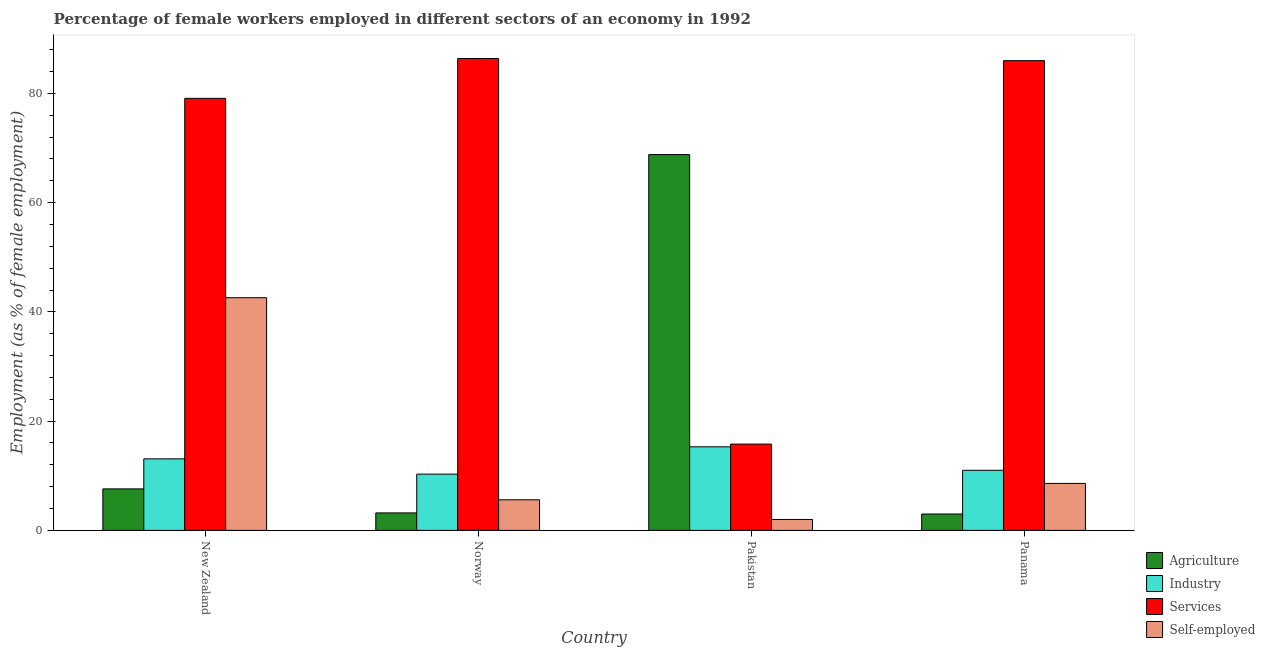How many groups of bars are there?
Offer a terse response. 4. Are the number of bars per tick equal to the number of legend labels?
Offer a very short reply. Yes. Are the number of bars on each tick of the X-axis equal?
Your answer should be very brief. Yes. How many bars are there on the 4th tick from the left?
Your response must be concise. 4. How many bars are there on the 3rd tick from the right?
Offer a terse response. 4. What is the label of the 4th group of bars from the left?
Make the answer very short. Panama. What is the percentage of female workers in services in Pakistan?
Make the answer very short. 15.8. Across all countries, what is the maximum percentage of female workers in services?
Offer a terse response. 86.4. Across all countries, what is the minimum percentage of self employed female workers?
Provide a succinct answer. 2. In which country was the percentage of female workers in industry minimum?
Offer a terse response. Norway. What is the total percentage of female workers in services in the graph?
Offer a terse response. 267.3. What is the difference between the percentage of female workers in industry in Norway and that in Pakistan?
Keep it short and to the point. -5. What is the difference between the percentage of female workers in agriculture in New Zealand and the percentage of self employed female workers in Pakistan?
Make the answer very short. 5.6. What is the average percentage of female workers in agriculture per country?
Give a very brief answer. 20.65. What is the difference between the percentage of female workers in services and percentage of female workers in industry in New Zealand?
Offer a terse response. 66. In how many countries, is the percentage of self employed female workers greater than 8 %?
Your answer should be very brief. 2. What is the ratio of the percentage of female workers in agriculture in Norway to that in Panama?
Give a very brief answer. 1.07. Is the percentage of female workers in industry in Norway less than that in Pakistan?
Provide a short and direct response. Yes. Is the difference between the percentage of female workers in industry in New Zealand and Norway greater than the difference between the percentage of self employed female workers in New Zealand and Norway?
Ensure brevity in your answer.  No. What is the difference between the highest and the second highest percentage of self employed female workers?
Ensure brevity in your answer.  34. Is it the case that in every country, the sum of the percentage of self employed female workers and percentage of female workers in services is greater than the sum of percentage of female workers in agriculture and percentage of female workers in industry?
Keep it short and to the point. No. What does the 3rd bar from the left in Pakistan represents?
Offer a very short reply. Services. What does the 1st bar from the right in Norway represents?
Your response must be concise. Self-employed. Is it the case that in every country, the sum of the percentage of female workers in agriculture and percentage of female workers in industry is greater than the percentage of female workers in services?
Give a very brief answer. No. What is the difference between two consecutive major ticks on the Y-axis?
Provide a short and direct response. 20. Are the values on the major ticks of Y-axis written in scientific E-notation?
Your answer should be very brief. No. Where does the legend appear in the graph?
Give a very brief answer. Bottom right. How are the legend labels stacked?
Offer a terse response. Vertical. What is the title of the graph?
Your answer should be compact. Percentage of female workers employed in different sectors of an economy in 1992. Does "First 20% of population" appear as one of the legend labels in the graph?
Provide a short and direct response. No. What is the label or title of the X-axis?
Your response must be concise. Country. What is the label or title of the Y-axis?
Offer a very short reply. Employment (as % of female employment). What is the Employment (as % of female employment) in Agriculture in New Zealand?
Your answer should be very brief. 7.6. What is the Employment (as % of female employment) in Industry in New Zealand?
Offer a terse response. 13.1. What is the Employment (as % of female employment) in Services in New Zealand?
Your answer should be compact. 79.1. What is the Employment (as % of female employment) of Self-employed in New Zealand?
Your response must be concise. 42.6. What is the Employment (as % of female employment) in Agriculture in Norway?
Provide a succinct answer. 3.2. What is the Employment (as % of female employment) in Industry in Norway?
Your answer should be very brief. 10.3. What is the Employment (as % of female employment) in Services in Norway?
Give a very brief answer. 86.4. What is the Employment (as % of female employment) in Self-employed in Norway?
Make the answer very short. 5.6. What is the Employment (as % of female employment) of Agriculture in Pakistan?
Your answer should be compact. 68.8. What is the Employment (as % of female employment) in Industry in Pakistan?
Your answer should be compact. 15.3. What is the Employment (as % of female employment) of Services in Pakistan?
Give a very brief answer. 15.8. What is the Employment (as % of female employment) of Industry in Panama?
Make the answer very short. 11. What is the Employment (as % of female employment) in Services in Panama?
Your answer should be compact. 86. What is the Employment (as % of female employment) of Self-employed in Panama?
Ensure brevity in your answer.  8.6. Across all countries, what is the maximum Employment (as % of female employment) of Agriculture?
Your response must be concise. 68.8. Across all countries, what is the maximum Employment (as % of female employment) of Industry?
Provide a short and direct response. 15.3. Across all countries, what is the maximum Employment (as % of female employment) in Services?
Give a very brief answer. 86.4. Across all countries, what is the maximum Employment (as % of female employment) of Self-employed?
Make the answer very short. 42.6. Across all countries, what is the minimum Employment (as % of female employment) in Agriculture?
Your response must be concise. 3. Across all countries, what is the minimum Employment (as % of female employment) of Industry?
Give a very brief answer. 10.3. Across all countries, what is the minimum Employment (as % of female employment) of Services?
Your response must be concise. 15.8. Across all countries, what is the minimum Employment (as % of female employment) in Self-employed?
Keep it short and to the point. 2. What is the total Employment (as % of female employment) of Agriculture in the graph?
Your answer should be very brief. 82.6. What is the total Employment (as % of female employment) of Industry in the graph?
Ensure brevity in your answer.  49.7. What is the total Employment (as % of female employment) in Services in the graph?
Provide a succinct answer. 267.3. What is the total Employment (as % of female employment) of Self-employed in the graph?
Give a very brief answer. 58.8. What is the difference between the Employment (as % of female employment) of Industry in New Zealand and that in Norway?
Offer a very short reply. 2.8. What is the difference between the Employment (as % of female employment) of Self-employed in New Zealand and that in Norway?
Your response must be concise. 37. What is the difference between the Employment (as % of female employment) in Agriculture in New Zealand and that in Pakistan?
Keep it short and to the point. -61.2. What is the difference between the Employment (as % of female employment) in Services in New Zealand and that in Pakistan?
Give a very brief answer. 63.3. What is the difference between the Employment (as % of female employment) of Self-employed in New Zealand and that in Pakistan?
Provide a short and direct response. 40.6. What is the difference between the Employment (as % of female employment) in Agriculture in Norway and that in Pakistan?
Offer a very short reply. -65.6. What is the difference between the Employment (as % of female employment) of Services in Norway and that in Pakistan?
Offer a very short reply. 70.6. What is the difference between the Employment (as % of female employment) of Self-employed in Norway and that in Pakistan?
Provide a short and direct response. 3.6. What is the difference between the Employment (as % of female employment) of Agriculture in Norway and that in Panama?
Your answer should be very brief. 0.2. What is the difference between the Employment (as % of female employment) of Agriculture in Pakistan and that in Panama?
Offer a very short reply. 65.8. What is the difference between the Employment (as % of female employment) in Industry in Pakistan and that in Panama?
Your response must be concise. 4.3. What is the difference between the Employment (as % of female employment) in Services in Pakistan and that in Panama?
Your response must be concise. -70.2. What is the difference between the Employment (as % of female employment) in Self-employed in Pakistan and that in Panama?
Offer a very short reply. -6.6. What is the difference between the Employment (as % of female employment) of Agriculture in New Zealand and the Employment (as % of female employment) of Industry in Norway?
Your response must be concise. -2.7. What is the difference between the Employment (as % of female employment) in Agriculture in New Zealand and the Employment (as % of female employment) in Services in Norway?
Keep it short and to the point. -78.8. What is the difference between the Employment (as % of female employment) of Industry in New Zealand and the Employment (as % of female employment) of Services in Norway?
Provide a short and direct response. -73.3. What is the difference between the Employment (as % of female employment) in Services in New Zealand and the Employment (as % of female employment) in Self-employed in Norway?
Keep it short and to the point. 73.5. What is the difference between the Employment (as % of female employment) of Agriculture in New Zealand and the Employment (as % of female employment) of Industry in Pakistan?
Your answer should be compact. -7.7. What is the difference between the Employment (as % of female employment) of Agriculture in New Zealand and the Employment (as % of female employment) of Services in Pakistan?
Your answer should be very brief. -8.2. What is the difference between the Employment (as % of female employment) of Industry in New Zealand and the Employment (as % of female employment) of Services in Pakistan?
Keep it short and to the point. -2.7. What is the difference between the Employment (as % of female employment) in Services in New Zealand and the Employment (as % of female employment) in Self-employed in Pakistan?
Make the answer very short. 77.1. What is the difference between the Employment (as % of female employment) of Agriculture in New Zealand and the Employment (as % of female employment) of Services in Panama?
Your answer should be very brief. -78.4. What is the difference between the Employment (as % of female employment) in Agriculture in New Zealand and the Employment (as % of female employment) in Self-employed in Panama?
Your answer should be very brief. -1. What is the difference between the Employment (as % of female employment) of Industry in New Zealand and the Employment (as % of female employment) of Services in Panama?
Give a very brief answer. -72.9. What is the difference between the Employment (as % of female employment) in Industry in New Zealand and the Employment (as % of female employment) in Self-employed in Panama?
Provide a succinct answer. 4.5. What is the difference between the Employment (as % of female employment) of Services in New Zealand and the Employment (as % of female employment) of Self-employed in Panama?
Make the answer very short. 70.5. What is the difference between the Employment (as % of female employment) of Agriculture in Norway and the Employment (as % of female employment) of Industry in Pakistan?
Keep it short and to the point. -12.1. What is the difference between the Employment (as % of female employment) of Agriculture in Norway and the Employment (as % of female employment) of Self-employed in Pakistan?
Ensure brevity in your answer.  1.2. What is the difference between the Employment (as % of female employment) in Services in Norway and the Employment (as % of female employment) in Self-employed in Pakistan?
Provide a succinct answer. 84.4. What is the difference between the Employment (as % of female employment) in Agriculture in Norway and the Employment (as % of female employment) in Services in Panama?
Provide a short and direct response. -82.8. What is the difference between the Employment (as % of female employment) of Agriculture in Norway and the Employment (as % of female employment) of Self-employed in Panama?
Your answer should be compact. -5.4. What is the difference between the Employment (as % of female employment) in Industry in Norway and the Employment (as % of female employment) in Services in Panama?
Your answer should be very brief. -75.7. What is the difference between the Employment (as % of female employment) of Industry in Norway and the Employment (as % of female employment) of Self-employed in Panama?
Offer a very short reply. 1.7. What is the difference between the Employment (as % of female employment) of Services in Norway and the Employment (as % of female employment) of Self-employed in Panama?
Provide a short and direct response. 77.8. What is the difference between the Employment (as % of female employment) in Agriculture in Pakistan and the Employment (as % of female employment) in Industry in Panama?
Offer a terse response. 57.8. What is the difference between the Employment (as % of female employment) of Agriculture in Pakistan and the Employment (as % of female employment) of Services in Panama?
Your response must be concise. -17.2. What is the difference between the Employment (as % of female employment) of Agriculture in Pakistan and the Employment (as % of female employment) of Self-employed in Panama?
Offer a very short reply. 60.2. What is the difference between the Employment (as % of female employment) in Industry in Pakistan and the Employment (as % of female employment) in Services in Panama?
Your answer should be compact. -70.7. What is the difference between the Employment (as % of female employment) of Industry in Pakistan and the Employment (as % of female employment) of Self-employed in Panama?
Make the answer very short. 6.7. What is the average Employment (as % of female employment) of Agriculture per country?
Give a very brief answer. 20.65. What is the average Employment (as % of female employment) in Industry per country?
Provide a succinct answer. 12.43. What is the average Employment (as % of female employment) in Services per country?
Give a very brief answer. 66.83. What is the difference between the Employment (as % of female employment) in Agriculture and Employment (as % of female employment) in Services in New Zealand?
Offer a terse response. -71.5. What is the difference between the Employment (as % of female employment) of Agriculture and Employment (as % of female employment) of Self-employed in New Zealand?
Your answer should be very brief. -35. What is the difference between the Employment (as % of female employment) of Industry and Employment (as % of female employment) of Services in New Zealand?
Make the answer very short. -66. What is the difference between the Employment (as % of female employment) of Industry and Employment (as % of female employment) of Self-employed in New Zealand?
Keep it short and to the point. -29.5. What is the difference between the Employment (as % of female employment) of Services and Employment (as % of female employment) of Self-employed in New Zealand?
Your answer should be compact. 36.5. What is the difference between the Employment (as % of female employment) of Agriculture and Employment (as % of female employment) of Industry in Norway?
Your answer should be very brief. -7.1. What is the difference between the Employment (as % of female employment) of Agriculture and Employment (as % of female employment) of Services in Norway?
Offer a terse response. -83.2. What is the difference between the Employment (as % of female employment) in Industry and Employment (as % of female employment) in Services in Norway?
Offer a terse response. -76.1. What is the difference between the Employment (as % of female employment) of Services and Employment (as % of female employment) of Self-employed in Norway?
Keep it short and to the point. 80.8. What is the difference between the Employment (as % of female employment) in Agriculture and Employment (as % of female employment) in Industry in Pakistan?
Make the answer very short. 53.5. What is the difference between the Employment (as % of female employment) of Agriculture and Employment (as % of female employment) of Services in Pakistan?
Make the answer very short. 53. What is the difference between the Employment (as % of female employment) of Agriculture and Employment (as % of female employment) of Self-employed in Pakistan?
Provide a succinct answer. 66.8. What is the difference between the Employment (as % of female employment) of Services and Employment (as % of female employment) of Self-employed in Pakistan?
Your answer should be compact. 13.8. What is the difference between the Employment (as % of female employment) in Agriculture and Employment (as % of female employment) in Industry in Panama?
Your response must be concise. -8. What is the difference between the Employment (as % of female employment) in Agriculture and Employment (as % of female employment) in Services in Panama?
Provide a succinct answer. -83. What is the difference between the Employment (as % of female employment) in Agriculture and Employment (as % of female employment) in Self-employed in Panama?
Offer a terse response. -5.6. What is the difference between the Employment (as % of female employment) in Industry and Employment (as % of female employment) in Services in Panama?
Provide a short and direct response. -75. What is the difference between the Employment (as % of female employment) in Services and Employment (as % of female employment) in Self-employed in Panama?
Give a very brief answer. 77.4. What is the ratio of the Employment (as % of female employment) of Agriculture in New Zealand to that in Norway?
Your answer should be very brief. 2.38. What is the ratio of the Employment (as % of female employment) of Industry in New Zealand to that in Norway?
Keep it short and to the point. 1.27. What is the ratio of the Employment (as % of female employment) of Services in New Zealand to that in Norway?
Your answer should be very brief. 0.92. What is the ratio of the Employment (as % of female employment) in Self-employed in New Zealand to that in Norway?
Offer a very short reply. 7.61. What is the ratio of the Employment (as % of female employment) of Agriculture in New Zealand to that in Pakistan?
Your answer should be very brief. 0.11. What is the ratio of the Employment (as % of female employment) of Industry in New Zealand to that in Pakistan?
Your answer should be very brief. 0.86. What is the ratio of the Employment (as % of female employment) in Services in New Zealand to that in Pakistan?
Ensure brevity in your answer.  5.01. What is the ratio of the Employment (as % of female employment) in Self-employed in New Zealand to that in Pakistan?
Your answer should be very brief. 21.3. What is the ratio of the Employment (as % of female employment) of Agriculture in New Zealand to that in Panama?
Keep it short and to the point. 2.53. What is the ratio of the Employment (as % of female employment) of Industry in New Zealand to that in Panama?
Give a very brief answer. 1.19. What is the ratio of the Employment (as % of female employment) of Services in New Zealand to that in Panama?
Provide a succinct answer. 0.92. What is the ratio of the Employment (as % of female employment) in Self-employed in New Zealand to that in Panama?
Your response must be concise. 4.95. What is the ratio of the Employment (as % of female employment) in Agriculture in Norway to that in Pakistan?
Provide a succinct answer. 0.05. What is the ratio of the Employment (as % of female employment) of Industry in Norway to that in Pakistan?
Keep it short and to the point. 0.67. What is the ratio of the Employment (as % of female employment) of Services in Norway to that in Pakistan?
Offer a terse response. 5.47. What is the ratio of the Employment (as % of female employment) in Agriculture in Norway to that in Panama?
Your response must be concise. 1.07. What is the ratio of the Employment (as % of female employment) of Industry in Norway to that in Panama?
Offer a terse response. 0.94. What is the ratio of the Employment (as % of female employment) in Self-employed in Norway to that in Panama?
Your answer should be compact. 0.65. What is the ratio of the Employment (as % of female employment) of Agriculture in Pakistan to that in Panama?
Offer a terse response. 22.93. What is the ratio of the Employment (as % of female employment) of Industry in Pakistan to that in Panama?
Make the answer very short. 1.39. What is the ratio of the Employment (as % of female employment) of Services in Pakistan to that in Panama?
Give a very brief answer. 0.18. What is the ratio of the Employment (as % of female employment) of Self-employed in Pakistan to that in Panama?
Your answer should be compact. 0.23. What is the difference between the highest and the second highest Employment (as % of female employment) in Agriculture?
Give a very brief answer. 61.2. What is the difference between the highest and the second highest Employment (as % of female employment) in Industry?
Give a very brief answer. 2.2. What is the difference between the highest and the lowest Employment (as % of female employment) in Agriculture?
Provide a succinct answer. 65.8. What is the difference between the highest and the lowest Employment (as % of female employment) in Services?
Keep it short and to the point. 70.6. What is the difference between the highest and the lowest Employment (as % of female employment) in Self-employed?
Offer a terse response. 40.6. 